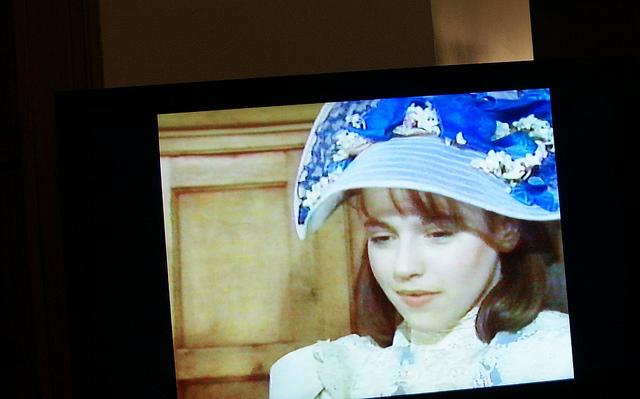Is the woman smiling?
Short answer required. No. Is the image straight?
Give a very brief answer. No. What type of hat is she wearing?
Write a very short answer. Blue. Is this an ornate hat?
Concise answer only. Yes. Is this on TV?
Short answer required. Yes. 